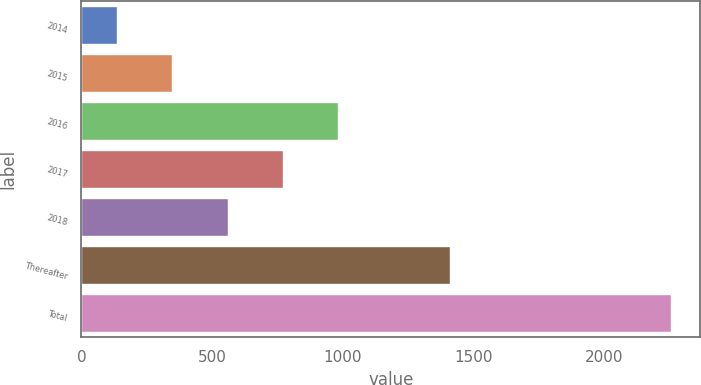<chart> <loc_0><loc_0><loc_500><loc_500><bar_chart><fcel>2014<fcel>2015<fcel>2016<fcel>2017<fcel>2018<fcel>Thereafter<fcel>Total<nl><fcel>136.1<fcel>347.81<fcel>982.94<fcel>771.23<fcel>559.52<fcel>1408.6<fcel>2253.2<nl></chart> 